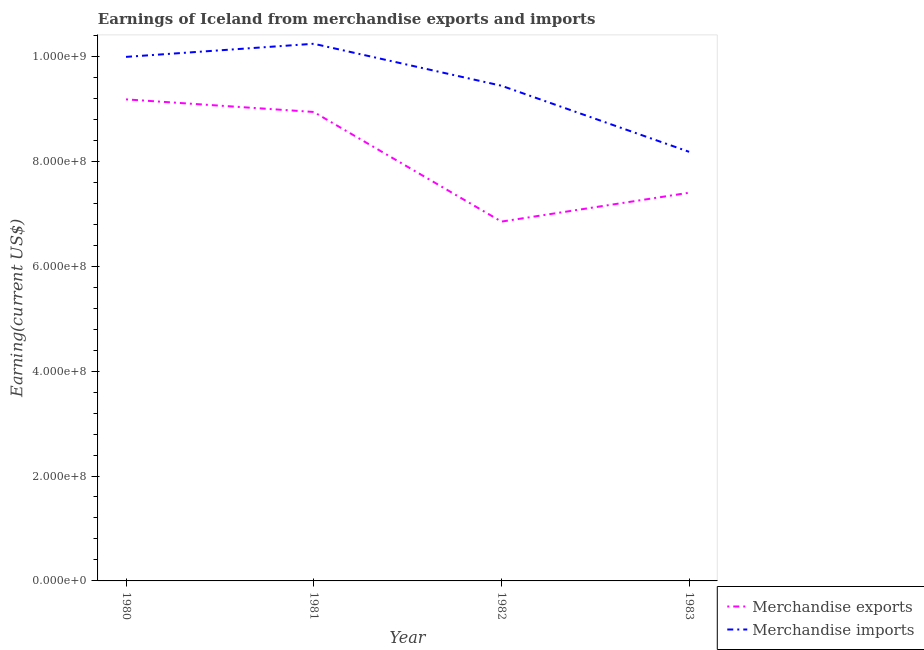Does the line corresponding to earnings from merchandise imports intersect with the line corresponding to earnings from merchandise exports?
Offer a terse response. No. What is the earnings from merchandise imports in 1980?
Your answer should be compact. 9.99e+08. Across all years, what is the maximum earnings from merchandise imports?
Your answer should be compact. 1.02e+09. Across all years, what is the minimum earnings from merchandise exports?
Provide a short and direct response. 6.85e+08. In which year was the earnings from merchandise exports minimum?
Make the answer very short. 1982. What is the total earnings from merchandise exports in the graph?
Provide a short and direct response. 3.24e+09. What is the difference between the earnings from merchandise imports in 1980 and that in 1982?
Ensure brevity in your answer.  5.50e+07. What is the difference between the earnings from merchandise exports in 1980 and the earnings from merchandise imports in 1983?
Provide a succinct answer. 1.00e+08. What is the average earnings from merchandise exports per year?
Keep it short and to the point. 8.09e+08. In the year 1982, what is the difference between the earnings from merchandise imports and earnings from merchandise exports?
Your answer should be compact. 2.59e+08. In how many years, is the earnings from merchandise exports greater than 200000000 US$?
Keep it short and to the point. 4. What is the ratio of the earnings from merchandise imports in 1980 to that in 1983?
Offer a very short reply. 1.22. Is the earnings from merchandise imports in 1980 less than that in 1983?
Give a very brief answer. No. Is the difference between the earnings from merchandise exports in 1980 and 1981 greater than the difference between the earnings from merchandise imports in 1980 and 1981?
Keep it short and to the point. Yes. What is the difference between the highest and the second highest earnings from merchandise exports?
Make the answer very short. 2.40e+07. What is the difference between the highest and the lowest earnings from merchandise imports?
Your answer should be compact. 2.06e+08. In how many years, is the earnings from merchandise exports greater than the average earnings from merchandise exports taken over all years?
Provide a short and direct response. 2. Is the sum of the earnings from merchandise exports in 1980 and 1983 greater than the maximum earnings from merchandise imports across all years?
Your answer should be compact. Yes. Does the earnings from merchandise imports monotonically increase over the years?
Make the answer very short. No. What is the difference between two consecutive major ticks on the Y-axis?
Your answer should be compact. 2.00e+08. Are the values on the major ticks of Y-axis written in scientific E-notation?
Keep it short and to the point. Yes. How many legend labels are there?
Provide a succinct answer. 2. How are the legend labels stacked?
Offer a terse response. Vertical. What is the title of the graph?
Keep it short and to the point. Earnings of Iceland from merchandise exports and imports. What is the label or title of the X-axis?
Your response must be concise. Year. What is the label or title of the Y-axis?
Offer a very short reply. Earning(current US$). What is the Earning(current US$) of Merchandise exports in 1980?
Your answer should be compact. 9.18e+08. What is the Earning(current US$) of Merchandise imports in 1980?
Your answer should be very brief. 9.99e+08. What is the Earning(current US$) in Merchandise exports in 1981?
Your response must be concise. 8.94e+08. What is the Earning(current US$) in Merchandise imports in 1981?
Make the answer very short. 1.02e+09. What is the Earning(current US$) of Merchandise exports in 1982?
Your response must be concise. 6.85e+08. What is the Earning(current US$) of Merchandise imports in 1982?
Provide a short and direct response. 9.44e+08. What is the Earning(current US$) of Merchandise exports in 1983?
Provide a short and direct response. 7.40e+08. What is the Earning(current US$) of Merchandise imports in 1983?
Give a very brief answer. 8.18e+08. Across all years, what is the maximum Earning(current US$) in Merchandise exports?
Your answer should be very brief. 9.18e+08. Across all years, what is the maximum Earning(current US$) in Merchandise imports?
Offer a very short reply. 1.02e+09. Across all years, what is the minimum Earning(current US$) in Merchandise exports?
Give a very brief answer. 6.85e+08. Across all years, what is the minimum Earning(current US$) in Merchandise imports?
Provide a succinct answer. 8.18e+08. What is the total Earning(current US$) in Merchandise exports in the graph?
Provide a short and direct response. 3.24e+09. What is the total Earning(current US$) in Merchandise imports in the graph?
Offer a very short reply. 3.78e+09. What is the difference between the Earning(current US$) of Merchandise exports in 1980 and that in 1981?
Give a very brief answer. 2.40e+07. What is the difference between the Earning(current US$) in Merchandise imports in 1980 and that in 1981?
Your response must be concise. -2.50e+07. What is the difference between the Earning(current US$) of Merchandise exports in 1980 and that in 1982?
Provide a succinct answer. 2.33e+08. What is the difference between the Earning(current US$) of Merchandise imports in 1980 and that in 1982?
Your answer should be very brief. 5.50e+07. What is the difference between the Earning(current US$) in Merchandise exports in 1980 and that in 1983?
Keep it short and to the point. 1.78e+08. What is the difference between the Earning(current US$) of Merchandise imports in 1980 and that in 1983?
Ensure brevity in your answer.  1.81e+08. What is the difference between the Earning(current US$) in Merchandise exports in 1981 and that in 1982?
Offer a terse response. 2.09e+08. What is the difference between the Earning(current US$) of Merchandise imports in 1981 and that in 1982?
Offer a very short reply. 8.00e+07. What is the difference between the Earning(current US$) in Merchandise exports in 1981 and that in 1983?
Offer a terse response. 1.54e+08. What is the difference between the Earning(current US$) in Merchandise imports in 1981 and that in 1983?
Your response must be concise. 2.06e+08. What is the difference between the Earning(current US$) of Merchandise exports in 1982 and that in 1983?
Give a very brief answer. -5.50e+07. What is the difference between the Earning(current US$) of Merchandise imports in 1982 and that in 1983?
Offer a very short reply. 1.26e+08. What is the difference between the Earning(current US$) in Merchandise exports in 1980 and the Earning(current US$) in Merchandise imports in 1981?
Your answer should be compact. -1.06e+08. What is the difference between the Earning(current US$) in Merchandise exports in 1980 and the Earning(current US$) in Merchandise imports in 1982?
Give a very brief answer. -2.60e+07. What is the difference between the Earning(current US$) in Merchandise exports in 1980 and the Earning(current US$) in Merchandise imports in 1983?
Your response must be concise. 1.00e+08. What is the difference between the Earning(current US$) in Merchandise exports in 1981 and the Earning(current US$) in Merchandise imports in 1982?
Offer a very short reply. -5.00e+07. What is the difference between the Earning(current US$) in Merchandise exports in 1981 and the Earning(current US$) in Merchandise imports in 1983?
Your answer should be very brief. 7.60e+07. What is the difference between the Earning(current US$) of Merchandise exports in 1982 and the Earning(current US$) of Merchandise imports in 1983?
Offer a very short reply. -1.33e+08. What is the average Earning(current US$) in Merchandise exports per year?
Your answer should be very brief. 8.09e+08. What is the average Earning(current US$) in Merchandise imports per year?
Provide a succinct answer. 9.46e+08. In the year 1980, what is the difference between the Earning(current US$) in Merchandise exports and Earning(current US$) in Merchandise imports?
Provide a succinct answer. -8.10e+07. In the year 1981, what is the difference between the Earning(current US$) in Merchandise exports and Earning(current US$) in Merchandise imports?
Your answer should be very brief. -1.30e+08. In the year 1982, what is the difference between the Earning(current US$) in Merchandise exports and Earning(current US$) in Merchandise imports?
Your response must be concise. -2.59e+08. In the year 1983, what is the difference between the Earning(current US$) of Merchandise exports and Earning(current US$) of Merchandise imports?
Your answer should be very brief. -7.80e+07. What is the ratio of the Earning(current US$) of Merchandise exports in 1980 to that in 1981?
Keep it short and to the point. 1.03. What is the ratio of the Earning(current US$) in Merchandise imports in 1980 to that in 1981?
Your response must be concise. 0.98. What is the ratio of the Earning(current US$) in Merchandise exports in 1980 to that in 1982?
Offer a very short reply. 1.34. What is the ratio of the Earning(current US$) in Merchandise imports in 1980 to that in 1982?
Your answer should be compact. 1.06. What is the ratio of the Earning(current US$) of Merchandise exports in 1980 to that in 1983?
Your answer should be very brief. 1.24. What is the ratio of the Earning(current US$) in Merchandise imports in 1980 to that in 1983?
Provide a short and direct response. 1.22. What is the ratio of the Earning(current US$) in Merchandise exports in 1981 to that in 1982?
Offer a terse response. 1.31. What is the ratio of the Earning(current US$) of Merchandise imports in 1981 to that in 1982?
Your answer should be very brief. 1.08. What is the ratio of the Earning(current US$) in Merchandise exports in 1981 to that in 1983?
Offer a terse response. 1.21. What is the ratio of the Earning(current US$) in Merchandise imports in 1981 to that in 1983?
Keep it short and to the point. 1.25. What is the ratio of the Earning(current US$) of Merchandise exports in 1982 to that in 1983?
Provide a short and direct response. 0.93. What is the ratio of the Earning(current US$) of Merchandise imports in 1982 to that in 1983?
Your answer should be compact. 1.15. What is the difference between the highest and the second highest Earning(current US$) of Merchandise exports?
Provide a succinct answer. 2.40e+07. What is the difference between the highest and the second highest Earning(current US$) of Merchandise imports?
Your answer should be compact. 2.50e+07. What is the difference between the highest and the lowest Earning(current US$) of Merchandise exports?
Make the answer very short. 2.33e+08. What is the difference between the highest and the lowest Earning(current US$) in Merchandise imports?
Your answer should be compact. 2.06e+08. 